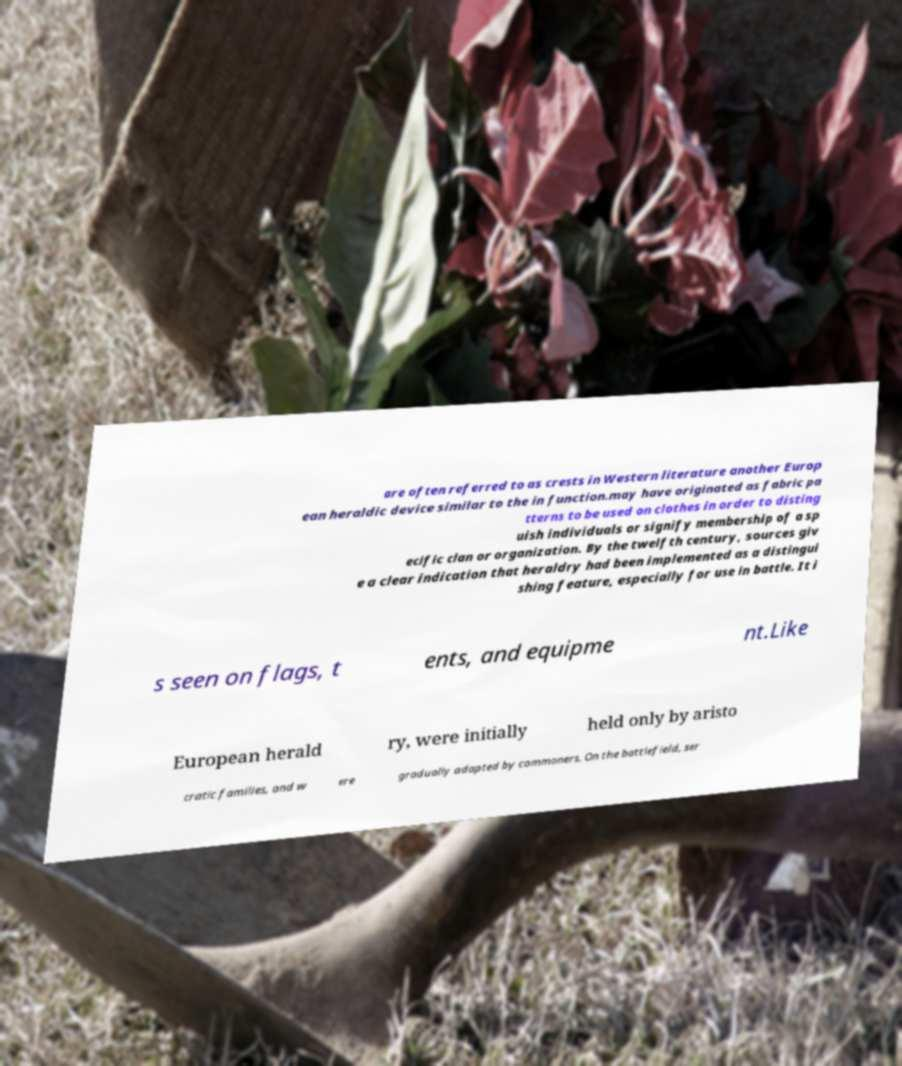Could you assist in decoding the text presented in this image and type it out clearly? are often referred to as crests in Western literature another Europ ean heraldic device similar to the in function.may have originated as fabric pa tterns to be used on clothes in order to disting uish individuals or signify membership of a sp ecific clan or organization. By the twelfth century, sources giv e a clear indication that heraldry had been implemented as a distingui shing feature, especially for use in battle. It i s seen on flags, t ents, and equipme nt.Like European herald ry, were initially held only by aristo cratic families, and w ere gradually adapted by commoners. On the battlefield, ser 